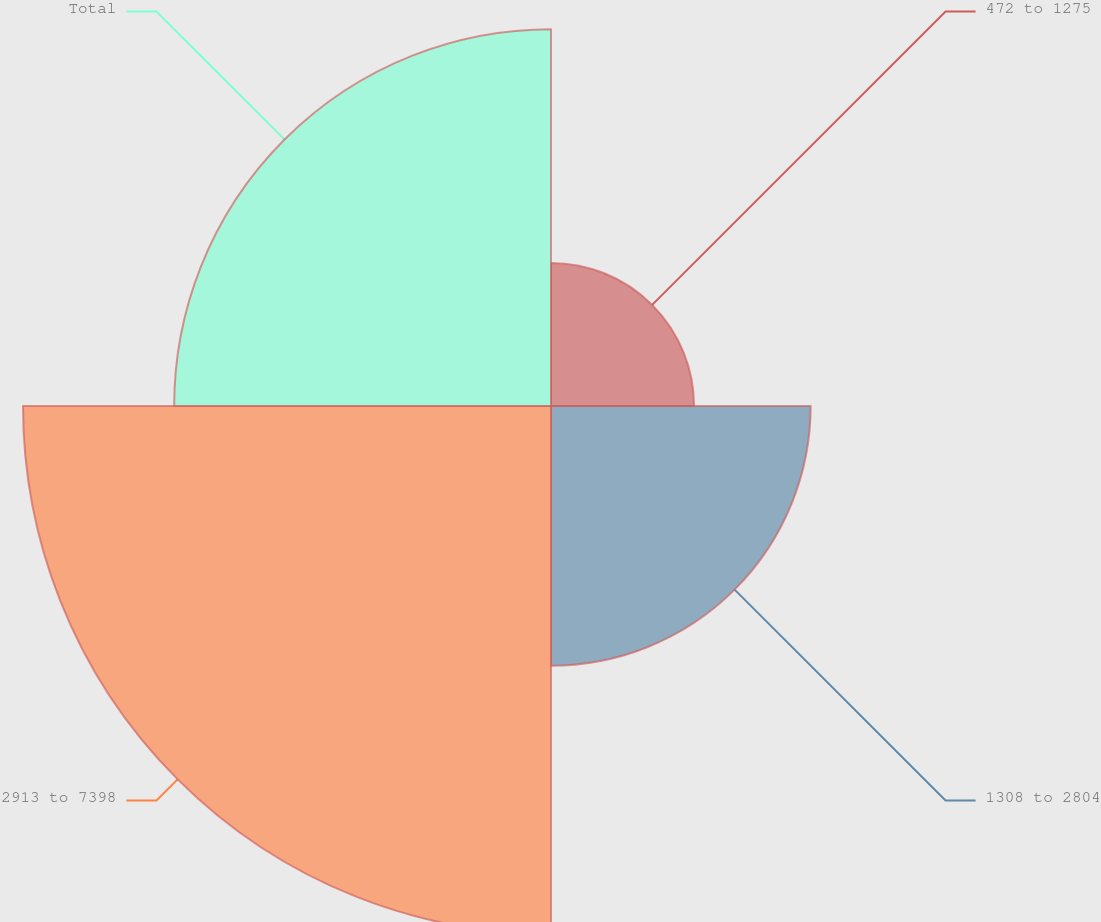Convert chart to OTSL. <chart><loc_0><loc_0><loc_500><loc_500><pie_chart><fcel>472 to 1275<fcel>1308 to 2804<fcel>2913 to 7398<fcel>Total<nl><fcel>10.94%<fcel>19.86%<fcel>40.38%<fcel>28.82%<nl></chart> 